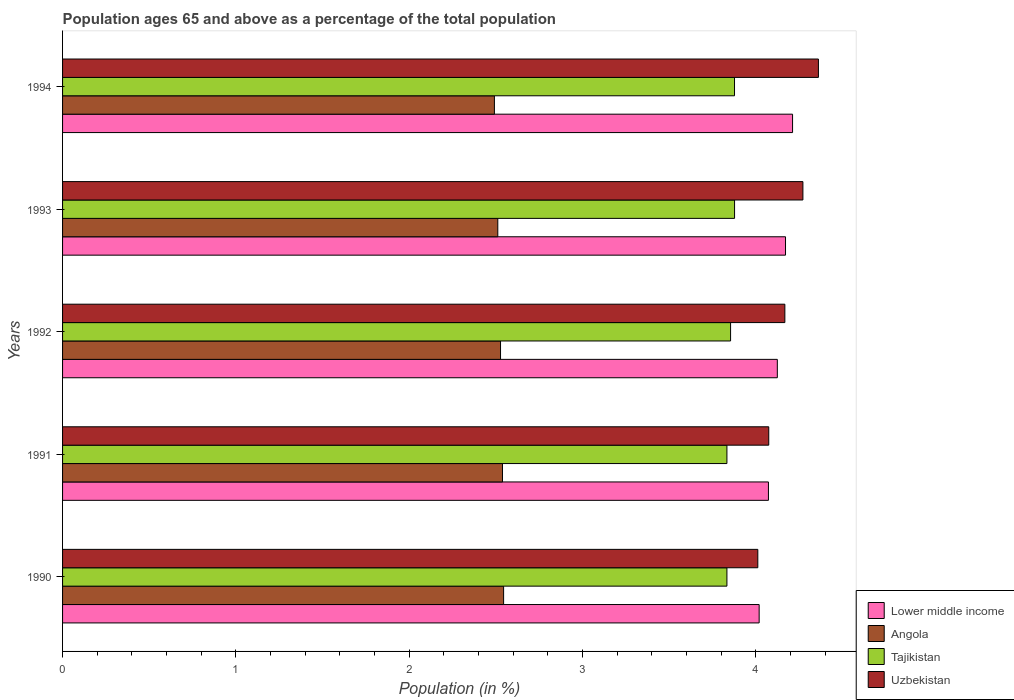How many different coloured bars are there?
Your answer should be compact. 4. How many groups of bars are there?
Your answer should be very brief. 5. Are the number of bars on each tick of the Y-axis equal?
Provide a succinct answer. Yes. How many bars are there on the 3rd tick from the bottom?
Your answer should be very brief. 4. What is the percentage of the population ages 65 and above in Tajikistan in 1993?
Give a very brief answer. 3.88. Across all years, what is the maximum percentage of the population ages 65 and above in Lower middle income?
Your answer should be compact. 4.21. Across all years, what is the minimum percentage of the population ages 65 and above in Tajikistan?
Your answer should be very brief. 3.83. What is the total percentage of the population ages 65 and above in Tajikistan in the graph?
Offer a terse response. 19.28. What is the difference between the percentage of the population ages 65 and above in Uzbekistan in 1992 and that in 1994?
Ensure brevity in your answer.  -0.19. What is the difference between the percentage of the population ages 65 and above in Uzbekistan in 1990 and the percentage of the population ages 65 and above in Tajikistan in 1993?
Keep it short and to the point. 0.13. What is the average percentage of the population ages 65 and above in Lower middle income per year?
Ensure brevity in your answer.  4.12. In the year 1994, what is the difference between the percentage of the population ages 65 and above in Lower middle income and percentage of the population ages 65 and above in Uzbekistan?
Offer a terse response. -0.15. What is the ratio of the percentage of the population ages 65 and above in Tajikistan in 1991 to that in 1994?
Offer a terse response. 0.99. Is the percentage of the population ages 65 and above in Lower middle income in 1991 less than that in 1993?
Your answer should be very brief. Yes. Is the difference between the percentage of the population ages 65 and above in Lower middle income in 1990 and 1991 greater than the difference between the percentage of the population ages 65 and above in Uzbekistan in 1990 and 1991?
Make the answer very short. Yes. What is the difference between the highest and the second highest percentage of the population ages 65 and above in Uzbekistan?
Give a very brief answer. 0.09. What is the difference between the highest and the lowest percentage of the population ages 65 and above in Uzbekistan?
Provide a short and direct response. 0.35. In how many years, is the percentage of the population ages 65 and above in Angola greater than the average percentage of the population ages 65 and above in Angola taken over all years?
Make the answer very short. 3. Is it the case that in every year, the sum of the percentage of the population ages 65 and above in Tajikistan and percentage of the population ages 65 and above in Uzbekistan is greater than the sum of percentage of the population ages 65 and above in Angola and percentage of the population ages 65 and above in Lower middle income?
Ensure brevity in your answer.  No. What does the 2nd bar from the top in 1993 represents?
Give a very brief answer. Tajikistan. What does the 2nd bar from the bottom in 1992 represents?
Provide a short and direct response. Angola. Are all the bars in the graph horizontal?
Keep it short and to the point. Yes. What is the difference between two consecutive major ticks on the X-axis?
Offer a terse response. 1. Does the graph contain any zero values?
Provide a succinct answer. No. Does the graph contain grids?
Offer a terse response. No. How many legend labels are there?
Keep it short and to the point. 4. How are the legend labels stacked?
Make the answer very short. Vertical. What is the title of the graph?
Offer a terse response. Population ages 65 and above as a percentage of the total population. Does "Kenya" appear as one of the legend labels in the graph?
Keep it short and to the point. No. What is the Population (in %) in Lower middle income in 1990?
Provide a succinct answer. 4.02. What is the Population (in %) of Angola in 1990?
Your answer should be very brief. 2.54. What is the Population (in %) in Tajikistan in 1990?
Keep it short and to the point. 3.83. What is the Population (in %) in Uzbekistan in 1990?
Make the answer very short. 4.01. What is the Population (in %) in Lower middle income in 1991?
Provide a succinct answer. 4.07. What is the Population (in %) of Angola in 1991?
Offer a very short reply. 2.54. What is the Population (in %) in Tajikistan in 1991?
Provide a short and direct response. 3.83. What is the Population (in %) of Uzbekistan in 1991?
Provide a short and direct response. 4.07. What is the Population (in %) of Lower middle income in 1992?
Make the answer very short. 4.12. What is the Population (in %) in Angola in 1992?
Provide a succinct answer. 2.53. What is the Population (in %) of Tajikistan in 1992?
Provide a short and direct response. 3.85. What is the Population (in %) in Uzbekistan in 1992?
Offer a very short reply. 4.17. What is the Population (in %) in Lower middle income in 1993?
Offer a terse response. 4.17. What is the Population (in %) in Angola in 1993?
Provide a short and direct response. 2.51. What is the Population (in %) of Tajikistan in 1993?
Offer a terse response. 3.88. What is the Population (in %) in Uzbekistan in 1993?
Give a very brief answer. 4.27. What is the Population (in %) in Lower middle income in 1994?
Give a very brief answer. 4.21. What is the Population (in %) of Angola in 1994?
Your answer should be compact. 2.49. What is the Population (in %) of Tajikistan in 1994?
Your answer should be very brief. 3.88. What is the Population (in %) of Uzbekistan in 1994?
Ensure brevity in your answer.  4.36. Across all years, what is the maximum Population (in %) in Lower middle income?
Your answer should be very brief. 4.21. Across all years, what is the maximum Population (in %) of Angola?
Your response must be concise. 2.54. Across all years, what is the maximum Population (in %) in Tajikistan?
Give a very brief answer. 3.88. Across all years, what is the maximum Population (in %) of Uzbekistan?
Provide a succinct answer. 4.36. Across all years, what is the minimum Population (in %) of Lower middle income?
Your response must be concise. 4.02. Across all years, what is the minimum Population (in %) in Angola?
Give a very brief answer. 2.49. Across all years, what is the minimum Population (in %) of Tajikistan?
Provide a succinct answer. 3.83. Across all years, what is the minimum Population (in %) in Uzbekistan?
Offer a very short reply. 4.01. What is the total Population (in %) of Lower middle income in the graph?
Make the answer very short. 20.6. What is the total Population (in %) in Angola in the graph?
Keep it short and to the point. 12.61. What is the total Population (in %) of Tajikistan in the graph?
Offer a terse response. 19.28. What is the total Population (in %) of Uzbekistan in the graph?
Ensure brevity in your answer.  20.89. What is the difference between the Population (in %) in Lower middle income in 1990 and that in 1991?
Provide a short and direct response. -0.05. What is the difference between the Population (in %) in Angola in 1990 and that in 1991?
Your response must be concise. 0.01. What is the difference between the Population (in %) in Uzbekistan in 1990 and that in 1991?
Make the answer very short. -0.06. What is the difference between the Population (in %) in Lower middle income in 1990 and that in 1992?
Your answer should be compact. -0.1. What is the difference between the Population (in %) of Angola in 1990 and that in 1992?
Give a very brief answer. 0.02. What is the difference between the Population (in %) in Tajikistan in 1990 and that in 1992?
Your answer should be very brief. -0.02. What is the difference between the Population (in %) of Uzbekistan in 1990 and that in 1992?
Provide a short and direct response. -0.16. What is the difference between the Population (in %) of Lower middle income in 1990 and that in 1993?
Make the answer very short. -0.15. What is the difference between the Population (in %) of Angola in 1990 and that in 1993?
Make the answer very short. 0.03. What is the difference between the Population (in %) in Tajikistan in 1990 and that in 1993?
Your response must be concise. -0.04. What is the difference between the Population (in %) in Uzbekistan in 1990 and that in 1993?
Offer a terse response. -0.26. What is the difference between the Population (in %) of Lower middle income in 1990 and that in 1994?
Your answer should be very brief. -0.19. What is the difference between the Population (in %) of Angola in 1990 and that in 1994?
Your answer should be very brief. 0.05. What is the difference between the Population (in %) in Tajikistan in 1990 and that in 1994?
Your answer should be very brief. -0.04. What is the difference between the Population (in %) of Uzbekistan in 1990 and that in 1994?
Your response must be concise. -0.35. What is the difference between the Population (in %) in Lower middle income in 1991 and that in 1992?
Your response must be concise. -0.05. What is the difference between the Population (in %) in Angola in 1991 and that in 1992?
Ensure brevity in your answer.  0.01. What is the difference between the Population (in %) of Tajikistan in 1991 and that in 1992?
Ensure brevity in your answer.  -0.02. What is the difference between the Population (in %) of Uzbekistan in 1991 and that in 1992?
Your response must be concise. -0.09. What is the difference between the Population (in %) in Lower middle income in 1991 and that in 1993?
Offer a terse response. -0.1. What is the difference between the Population (in %) in Angola in 1991 and that in 1993?
Your answer should be very brief. 0.03. What is the difference between the Population (in %) in Tajikistan in 1991 and that in 1993?
Provide a short and direct response. -0.04. What is the difference between the Population (in %) in Uzbekistan in 1991 and that in 1993?
Provide a succinct answer. -0.2. What is the difference between the Population (in %) of Lower middle income in 1991 and that in 1994?
Give a very brief answer. -0.14. What is the difference between the Population (in %) of Angola in 1991 and that in 1994?
Your answer should be compact. 0.05. What is the difference between the Population (in %) of Tajikistan in 1991 and that in 1994?
Provide a short and direct response. -0.04. What is the difference between the Population (in %) in Uzbekistan in 1991 and that in 1994?
Make the answer very short. -0.29. What is the difference between the Population (in %) in Lower middle income in 1992 and that in 1993?
Keep it short and to the point. -0.05. What is the difference between the Population (in %) in Angola in 1992 and that in 1993?
Provide a short and direct response. 0.02. What is the difference between the Population (in %) in Tajikistan in 1992 and that in 1993?
Make the answer very short. -0.02. What is the difference between the Population (in %) of Uzbekistan in 1992 and that in 1993?
Your response must be concise. -0.1. What is the difference between the Population (in %) of Lower middle income in 1992 and that in 1994?
Your answer should be compact. -0.09. What is the difference between the Population (in %) of Angola in 1992 and that in 1994?
Keep it short and to the point. 0.04. What is the difference between the Population (in %) of Tajikistan in 1992 and that in 1994?
Your response must be concise. -0.02. What is the difference between the Population (in %) of Uzbekistan in 1992 and that in 1994?
Your answer should be very brief. -0.19. What is the difference between the Population (in %) of Lower middle income in 1993 and that in 1994?
Your answer should be very brief. -0.04. What is the difference between the Population (in %) of Angola in 1993 and that in 1994?
Provide a short and direct response. 0.02. What is the difference between the Population (in %) in Uzbekistan in 1993 and that in 1994?
Provide a succinct answer. -0.09. What is the difference between the Population (in %) of Lower middle income in 1990 and the Population (in %) of Angola in 1991?
Offer a terse response. 1.48. What is the difference between the Population (in %) in Lower middle income in 1990 and the Population (in %) in Tajikistan in 1991?
Ensure brevity in your answer.  0.19. What is the difference between the Population (in %) in Lower middle income in 1990 and the Population (in %) in Uzbekistan in 1991?
Make the answer very short. -0.06. What is the difference between the Population (in %) in Angola in 1990 and the Population (in %) in Tajikistan in 1991?
Keep it short and to the point. -1.29. What is the difference between the Population (in %) of Angola in 1990 and the Population (in %) of Uzbekistan in 1991?
Give a very brief answer. -1.53. What is the difference between the Population (in %) in Tajikistan in 1990 and the Population (in %) in Uzbekistan in 1991?
Provide a short and direct response. -0.24. What is the difference between the Population (in %) in Lower middle income in 1990 and the Population (in %) in Angola in 1992?
Ensure brevity in your answer.  1.49. What is the difference between the Population (in %) in Lower middle income in 1990 and the Population (in %) in Tajikistan in 1992?
Make the answer very short. 0.16. What is the difference between the Population (in %) in Lower middle income in 1990 and the Population (in %) in Uzbekistan in 1992?
Offer a terse response. -0.15. What is the difference between the Population (in %) in Angola in 1990 and the Population (in %) in Tajikistan in 1992?
Ensure brevity in your answer.  -1.31. What is the difference between the Population (in %) of Angola in 1990 and the Population (in %) of Uzbekistan in 1992?
Keep it short and to the point. -1.62. What is the difference between the Population (in %) in Tajikistan in 1990 and the Population (in %) in Uzbekistan in 1992?
Keep it short and to the point. -0.33. What is the difference between the Population (in %) of Lower middle income in 1990 and the Population (in %) of Angola in 1993?
Make the answer very short. 1.51. What is the difference between the Population (in %) of Lower middle income in 1990 and the Population (in %) of Tajikistan in 1993?
Give a very brief answer. 0.14. What is the difference between the Population (in %) of Lower middle income in 1990 and the Population (in %) of Uzbekistan in 1993?
Make the answer very short. -0.25. What is the difference between the Population (in %) of Angola in 1990 and the Population (in %) of Tajikistan in 1993?
Ensure brevity in your answer.  -1.33. What is the difference between the Population (in %) of Angola in 1990 and the Population (in %) of Uzbekistan in 1993?
Keep it short and to the point. -1.73. What is the difference between the Population (in %) in Tajikistan in 1990 and the Population (in %) in Uzbekistan in 1993?
Make the answer very short. -0.44. What is the difference between the Population (in %) in Lower middle income in 1990 and the Population (in %) in Angola in 1994?
Provide a succinct answer. 1.53. What is the difference between the Population (in %) in Lower middle income in 1990 and the Population (in %) in Tajikistan in 1994?
Ensure brevity in your answer.  0.14. What is the difference between the Population (in %) in Lower middle income in 1990 and the Population (in %) in Uzbekistan in 1994?
Provide a short and direct response. -0.34. What is the difference between the Population (in %) in Angola in 1990 and the Population (in %) in Tajikistan in 1994?
Keep it short and to the point. -1.33. What is the difference between the Population (in %) in Angola in 1990 and the Population (in %) in Uzbekistan in 1994?
Make the answer very short. -1.82. What is the difference between the Population (in %) in Tajikistan in 1990 and the Population (in %) in Uzbekistan in 1994?
Give a very brief answer. -0.53. What is the difference between the Population (in %) in Lower middle income in 1991 and the Population (in %) in Angola in 1992?
Offer a terse response. 1.55. What is the difference between the Population (in %) in Lower middle income in 1991 and the Population (in %) in Tajikistan in 1992?
Your answer should be compact. 0.22. What is the difference between the Population (in %) in Lower middle income in 1991 and the Population (in %) in Uzbekistan in 1992?
Your answer should be compact. -0.09. What is the difference between the Population (in %) in Angola in 1991 and the Population (in %) in Tajikistan in 1992?
Your answer should be compact. -1.32. What is the difference between the Population (in %) of Angola in 1991 and the Population (in %) of Uzbekistan in 1992?
Your answer should be compact. -1.63. What is the difference between the Population (in %) in Tajikistan in 1991 and the Population (in %) in Uzbekistan in 1992?
Provide a succinct answer. -0.33. What is the difference between the Population (in %) in Lower middle income in 1991 and the Population (in %) in Angola in 1993?
Your answer should be very brief. 1.56. What is the difference between the Population (in %) in Lower middle income in 1991 and the Population (in %) in Tajikistan in 1993?
Your answer should be very brief. 0.2. What is the difference between the Population (in %) of Lower middle income in 1991 and the Population (in %) of Uzbekistan in 1993?
Provide a short and direct response. -0.2. What is the difference between the Population (in %) of Angola in 1991 and the Population (in %) of Tajikistan in 1993?
Your answer should be compact. -1.34. What is the difference between the Population (in %) in Angola in 1991 and the Population (in %) in Uzbekistan in 1993?
Your answer should be compact. -1.73. What is the difference between the Population (in %) in Tajikistan in 1991 and the Population (in %) in Uzbekistan in 1993?
Your answer should be compact. -0.44. What is the difference between the Population (in %) in Lower middle income in 1991 and the Population (in %) in Angola in 1994?
Offer a very short reply. 1.58. What is the difference between the Population (in %) of Lower middle income in 1991 and the Population (in %) of Tajikistan in 1994?
Make the answer very short. 0.2. What is the difference between the Population (in %) of Lower middle income in 1991 and the Population (in %) of Uzbekistan in 1994?
Provide a succinct answer. -0.29. What is the difference between the Population (in %) in Angola in 1991 and the Population (in %) in Tajikistan in 1994?
Ensure brevity in your answer.  -1.34. What is the difference between the Population (in %) of Angola in 1991 and the Population (in %) of Uzbekistan in 1994?
Provide a succinct answer. -1.82. What is the difference between the Population (in %) in Tajikistan in 1991 and the Population (in %) in Uzbekistan in 1994?
Your answer should be very brief. -0.53. What is the difference between the Population (in %) in Lower middle income in 1992 and the Population (in %) in Angola in 1993?
Keep it short and to the point. 1.61. What is the difference between the Population (in %) of Lower middle income in 1992 and the Population (in %) of Tajikistan in 1993?
Keep it short and to the point. 0.25. What is the difference between the Population (in %) in Lower middle income in 1992 and the Population (in %) in Uzbekistan in 1993?
Offer a very short reply. -0.15. What is the difference between the Population (in %) of Angola in 1992 and the Population (in %) of Tajikistan in 1993?
Your answer should be very brief. -1.35. What is the difference between the Population (in %) in Angola in 1992 and the Population (in %) in Uzbekistan in 1993?
Offer a terse response. -1.74. What is the difference between the Population (in %) in Tajikistan in 1992 and the Population (in %) in Uzbekistan in 1993?
Provide a succinct answer. -0.42. What is the difference between the Population (in %) of Lower middle income in 1992 and the Population (in %) of Angola in 1994?
Your answer should be compact. 1.63. What is the difference between the Population (in %) of Lower middle income in 1992 and the Population (in %) of Tajikistan in 1994?
Provide a short and direct response. 0.25. What is the difference between the Population (in %) of Lower middle income in 1992 and the Population (in %) of Uzbekistan in 1994?
Provide a short and direct response. -0.24. What is the difference between the Population (in %) in Angola in 1992 and the Population (in %) in Tajikistan in 1994?
Provide a succinct answer. -1.35. What is the difference between the Population (in %) of Angola in 1992 and the Population (in %) of Uzbekistan in 1994?
Your response must be concise. -1.83. What is the difference between the Population (in %) of Tajikistan in 1992 and the Population (in %) of Uzbekistan in 1994?
Your answer should be very brief. -0.51. What is the difference between the Population (in %) in Lower middle income in 1993 and the Population (in %) in Angola in 1994?
Your response must be concise. 1.68. What is the difference between the Population (in %) in Lower middle income in 1993 and the Population (in %) in Tajikistan in 1994?
Your answer should be compact. 0.29. What is the difference between the Population (in %) in Lower middle income in 1993 and the Population (in %) in Uzbekistan in 1994?
Your response must be concise. -0.19. What is the difference between the Population (in %) of Angola in 1993 and the Population (in %) of Tajikistan in 1994?
Make the answer very short. -1.37. What is the difference between the Population (in %) of Angola in 1993 and the Population (in %) of Uzbekistan in 1994?
Provide a succinct answer. -1.85. What is the difference between the Population (in %) in Tajikistan in 1993 and the Population (in %) in Uzbekistan in 1994?
Offer a terse response. -0.48. What is the average Population (in %) of Lower middle income per year?
Give a very brief answer. 4.12. What is the average Population (in %) of Angola per year?
Your answer should be compact. 2.52. What is the average Population (in %) of Tajikistan per year?
Provide a short and direct response. 3.86. What is the average Population (in %) in Uzbekistan per year?
Your response must be concise. 4.18. In the year 1990, what is the difference between the Population (in %) in Lower middle income and Population (in %) in Angola?
Make the answer very short. 1.47. In the year 1990, what is the difference between the Population (in %) of Lower middle income and Population (in %) of Tajikistan?
Offer a very short reply. 0.19. In the year 1990, what is the difference between the Population (in %) of Lower middle income and Population (in %) of Uzbekistan?
Keep it short and to the point. 0.01. In the year 1990, what is the difference between the Population (in %) of Angola and Population (in %) of Tajikistan?
Your answer should be very brief. -1.29. In the year 1990, what is the difference between the Population (in %) of Angola and Population (in %) of Uzbekistan?
Your answer should be very brief. -1.47. In the year 1990, what is the difference between the Population (in %) of Tajikistan and Population (in %) of Uzbekistan?
Keep it short and to the point. -0.18. In the year 1991, what is the difference between the Population (in %) of Lower middle income and Population (in %) of Angola?
Your response must be concise. 1.53. In the year 1991, what is the difference between the Population (in %) in Lower middle income and Population (in %) in Tajikistan?
Provide a short and direct response. 0.24. In the year 1991, what is the difference between the Population (in %) of Lower middle income and Population (in %) of Uzbekistan?
Ensure brevity in your answer.  -0. In the year 1991, what is the difference between the Population (in %) in Angola and Population (in %) in Tajikistan?
Your answer should be compact. -1.29. In the year 1991, what is the difference between the Population (in %) of Angola and Population (in %) of Uzbekistan?
Offer a very short reply. -1.54. In the year 1991, what is the difference between the Population (in %) in Tajikistan and Population (in %) in Uzbekistan?
Ensure brevity in your answer.  -0.24. In the year 1992, what is the difference between the Population (in %) of Lower middle income and Population (in %) of Angola?
Your response must be concise. 1.6. In the year 1992, what is the difference between the Population (in %) in Lower middle income and Population (in %) in Tajikistan?
Provide a succinct answer. 0.27. In the year 1992, what is the difference between the Population (in %) of Lower middle income and Population (in %) of Uzbekistan?
Provide a succinct answer. -0.04. In the year 1992, what is the difference between the Population (in %) in Angola and Population (in %) in Tajikistan?
Make the answer very short. -1.33. In the year 1992, what is the difference between the Population (in %) of Angola and Population (in %) of Uzbekistan?
Make the answer very short. -1.64. In the year 1992, what is the difference between the Population (in %) in Tajikistan and Population (in %) in Uzbekistan?
Ensure brevity in your answer.  -0.31. In the year 1993, what is the difference between the Population (in %) of Lower middle income and Population (in %) of Angola?
Make the answer very short. 1.66. In the year 1993, what is the difference between the Population (in %) of Lower middle income and Population (in %) of Tajikistan?
Your answer should be compact. 0.29. In the year 1993, what is the difference between the Population (in %) of Lower middle income and Population (in %) of Uzbekistan?
Your answer should be very brief. -0.1. In the year 1993, what is the difference between the Population (in %) in Angola and Population (in %) in Tajikistan?
Your answer should be very brief. -1.37. In the year 1993, what is the difference between the Population (in %) of Angola and Population (in %) of Uzbekistan?
Offer a terse response. -1.76. In the year 1993, what is the difference between the Population (in %) of Tajikistan and Population (in %) of Uzbekistan?
Offer a very short reply. -0.39. In the year 1994, what is the difference between the Population (in %) in Lower middle income and Population (in %) in Angola?
Make the answer very short. 1.72. In the year 1994, what is the difference between the Population (in %) of Lower middle income and Population (in %) of Tajikistan?
Offer a very short reply. 0.33. In the year 1994, what is the difference between the Population (in %) of Lower middle income and Population (in %) of Uzbekistan?
Your response must be concise. -0.15. In the year 1994, what is the difference between the Population (in %) of Angola and Population (in %) of Tajikistan?
Your answer should be very brief. -1.39. In the year 1994, what is the difference between the Population (in %) in Angola and Population (in %) in Uzbekistan?
Your response must be concise. -1.87. In the year 1994, what is the difference between the Population (in %) in Tajikistan and Population (in %) in Uzbekistan?
Your answer should be very brief. -0.48. What is the ratio of the Population (in %) in Lower middle income in 1990 to that in 1991?
Your answer should be very brief. 0.99. What is the ratio of the Population (in %) in Tajikistan in 1990 to that in 1991?
Give a very brief answer. 1. What is the ratio of the Population (in %) in Uzbekistan in 1990 to that in 1991?
Provide a succinct answer. 0.98. What is the ratio of the Population (in %) in Lower middle income in 1990 to that in 1992?
Ensure brevity in your answer.  0.97. What is the ratio of the Population (in %) in Tajikistan in 1990 to that in 1992?
Your answer should be very brief. 0.99. What is the ratio of the Population (in %) in Uzbekistan in 1990 to that in 1992?
Your response must be concise. 0.96. What is the ratio of the Population (in %) in Lower middle income in 1990 to that in 1993?
Offer a very short reply. 0.96. What is the ratio of the Population (in %) of Angola in 1990 to that in 1993?
Provide a succinct answer. 1.01. What is the ratio of the Population (in %) in Tajikistan in 1990 to that in 1993?
Provide a short and direct response. 0.99. What is the ratio of the Population (in %) in Uzbekistan in 1990 to that in 1993?
Your answer should be compact. 0.94. What is the ratio of the Population (in %) of Lower middle income in 1990 to that in 1994?
Provide a succinct answer. 0.95. What is the ratio of the Population (in %) in Angola in 1990 to that in 1994?
Provide a short and direct response. 1.02. What is the ratio of the Population (in %) of Tajikistan in 1990 to that in 1994?
Provide a succinct answer. 0.99. What is the ratio of the Population (in %) in Uzbekistan in 1990 to that in 1994?
Your answer should be very brief. 0.92. What is the ratio of the Population (in %) of Lower middle income in 1991 to that in 1992?
Provide a succinct answer. 0.99. What is the ratio of the Population (in %) in Uzbekistan in 1991 to that in 1992?
Offer a terse response. 0.98. What is the ratio of the Population (in %) in Lower middle income in 1991 to that in 1993?
Your answer should be very brief. 0.98. What is the ratio of the Population (in %) in Angola in 1991 to that in 1993?
Offer a very short reply. 1.01. What is the ratio of the Population (in %) of Tajikistan in 1991 to that in 1993?
Offer a very short reply. 0.99. What is the ratio of the Population (in %) in Uzbekistan in 1991 to that in 1993?
Keep it short and to the point. 0.95. What is the ratio of the Population (in %) in Lower middle income in 1991 to that in 1994?
Ensure brevity in your answer.  0.97. What is the ratio of the Population (in %) of Angola in 1991 to that in 1994?
Ensure brevity in your answer.  1.02. What is the ratio of the Population (in %) of Tajikistan in 1991 to that in 1994?
Your answer should be very brief. 0.99. What is the ratio of the Population (in %) of Uzbekistan in 1991 to that in 1994?
Offer a very short reply. 0.93. What is the ratio of the Population (in %) in Lower middle income in 1992 to that in 1993?
Your answer should be compact. 0.99. What is the ratio of the Population (in %) in Angola in 1992 to that in 1993?
Your answer should be compact. 1.01. What is the ratio of the Population (in %) of Uzbekistan in 1992 to that in 1993?
Your answer should be very brief. 0.98. What is the ratio of the Population (in %) of Lower middle income in 1992 to that in 1994?
Offer a terse response. 0.98. What is the ratio of the Population (in %) of Angola in 1992 to that in 1994?
Provide a succinct answer. 1.01. What is the ratio of the Population (in %) of Uzbekistan in 1992 to that in 1994?
Provide a short and direct response. 0.96. What is the ratio of the Population (in %) of Lower middle income in 1993 to that in 1994?
Ensure brevity in your answer.  0.99. What is the ratio of the Population (in %) of Angola in 1993 to that in 1994?
Ensure brevity in your answer.  1.01. What is the ratio of the Population (in %) of Tajikistan in 1993 to that in 1994?
Give a very brief answer. 1. What is the ratio of the Population (in %) in Uzbekistan in 1993 to that in 1994?
Offer a very short reply. 0.98. What is the difference between the highest and the second highest Population (in %) in Lower middle income?
Give a very brief answer. 0.04. What is the difference between the highest and the second highest Population (in %) of Angola?
Make the answer very short. 0.01. What is the difference between the highest and the second highest Population (in %) in Uzbekistan?
Offer a terse response. 0.09. What is the difference between the highest and the lowest Population (in %) of Lower middle income?
Keep it short and to the point. 0.19. What is the difference between the highest and the lowest Population (in %) in Angola?
Keep it short and to the point. 0.05. What is the difference between the highest and the lowest Population (in %) in Tajikistan?
Offer a very short reply. 0.04. What is the difference between the highest and the lowest Population (in %) in Uzbekistan?
Offer a very short reply. 0.35. 